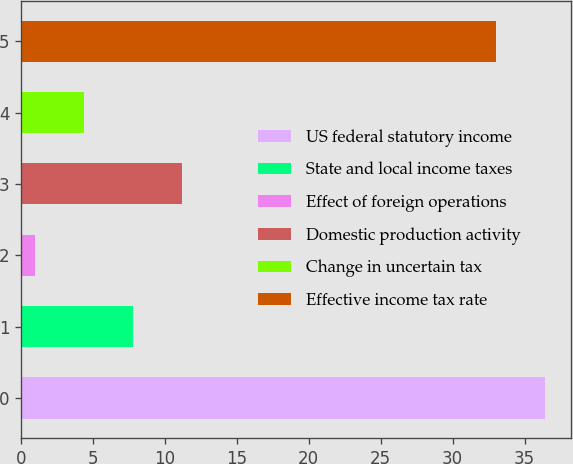Convert chart. <chart><loc_0><loc_0><loc_500><loc_500><bar_chart><fcel>US federal statutory income<fcel>State and local income taxes<fcel>Effect of foreign operations<fcel>Domestic production activity<fcel>Change in uncertain tax<fcel>Effective income tax rate<nl><fcel>36.4<fcel>7.8<fcel>1<fcel>11.2<fcel>4.4<fcel>33<nl></chart> 